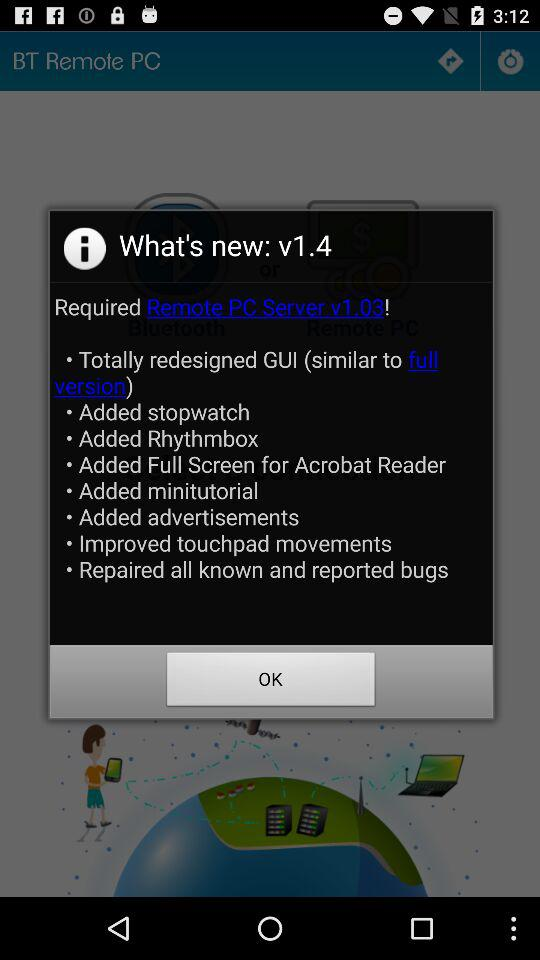How many items are added to the application that are not ads?
Answer the question using a single word or phrase. 6 